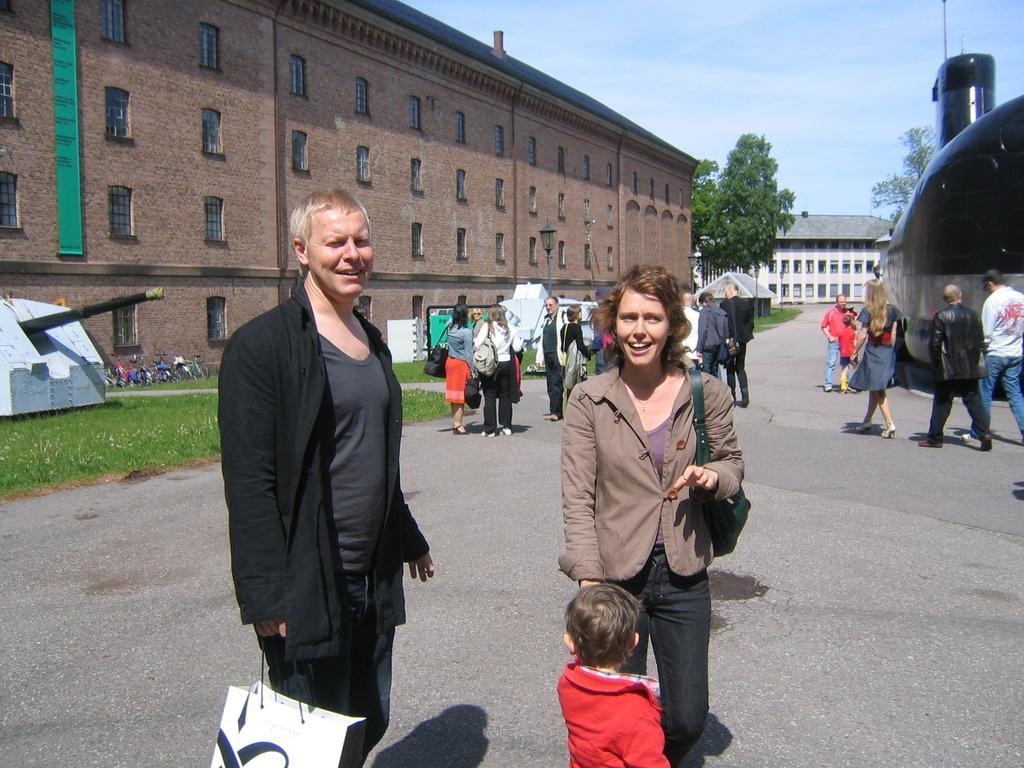Can you describe this image briefly? In front of the image there is a man and a lady. They both are standing. And also there is a kid. Behind them on the road there are few people walking. On the left side of the image, on the ground there is grass and also there are few machines and some things on it. On the right side of the image there is a submarine. In the background there are buildings with walls, windows and roofs. And also there are trees. At the top of the image there is sky. 